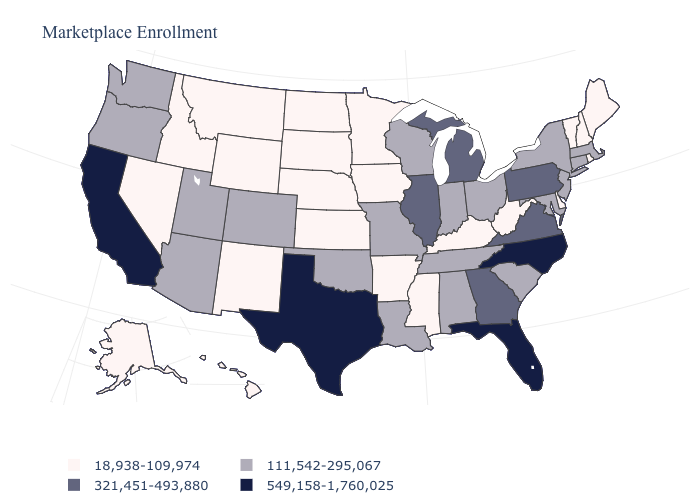Does California have the highest value in the USA?
Concise answer only. Yes. What is the value of Alabama?
Keep it brief. 111,542-295,067. Which states hav the highest value in the Northeast?
Short answer required. Pennsylvania. What is the value of Iowa?
Keep it brief. 18,938-109,974. Which states have the lowest value in the MidWest?
Concise answer only. Iowa, Kansas, Minnesota, Nebraska, North Dakota, South Dakota. Does New Hampshire have the highest value in the Northeast?
Write a very short answer. No. Name the states that have a value in the range 549,158-1,760,025?
Write a very short answer. California, Florida, North Carolina, Texas. What is the lowest value in the USA?
Be succinct. 18,938-109,974. Name the states that have a value in the range 549,158-1,760,025?
Give a very brief answer. California, Florida, North Carolina, Texas. Which states have the lowest value in the USA?
Answer briefly. Alaska, Arkansas, Delaware, Hawaii, Idaho, Iowa, Kansas, Kentucky, Maine, Minnesota, Mississippi, Montana, Nebraska, Nevada, New Hampshire, New Mexico, North Dakota, Rhode Island, South Dakota, Vermont, West Virginia, Wyoming. Name the states that have a value in the range 111,542-295,067?
Answer briefly. Alabama, Arizona, Colorado, Connecticut, Indiana, Louisiana, Maryland, Massachusetts, Missouri, New Jersey, New York, Ohio, Oklahoma, Oregon, South Carolina, Tennessee, Utah, Washington, Wisconsin. What is the value of Maryland?
Keep it brief. 111,542-295,067. Which states have the highest value in the USA?
Answer briefly. California, Florida, North Carolina, Texas. What is the highest value in states that border Minnesota?
Quick response, please. 111,542-295,067. 